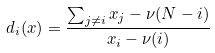<formula> <loc_0><loc_0><loc_500><loc_500>d _ { i } ( x ) = \frac { \sum _ { j \neq i } x _ { j } - \nu ( N - i ) } { x _ { i } - \nu ( i ) }</formula> 